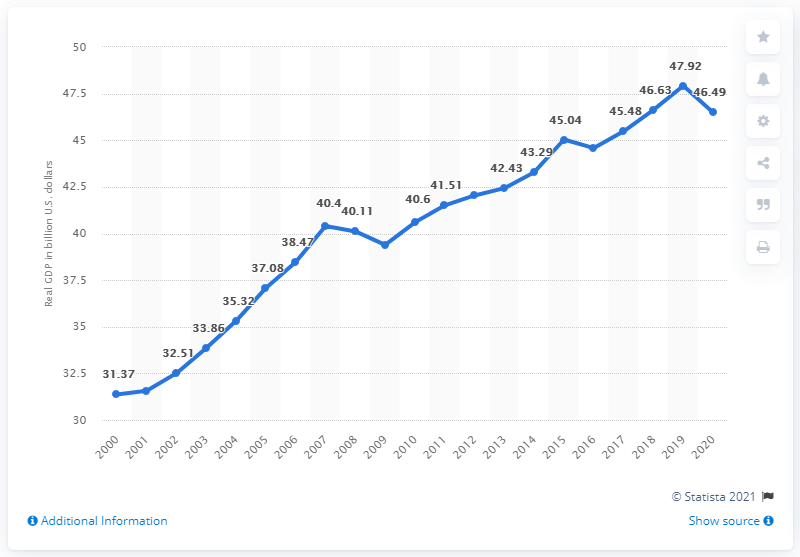Mention a couple of crucial points in this snapshot. In 2020, the Gross Domestic Product (GDP) of Montana was 46.49 billion dollars. In 2018, the Gross Domestic Product (GDP) of Montana was 47.92 billion dollars. 